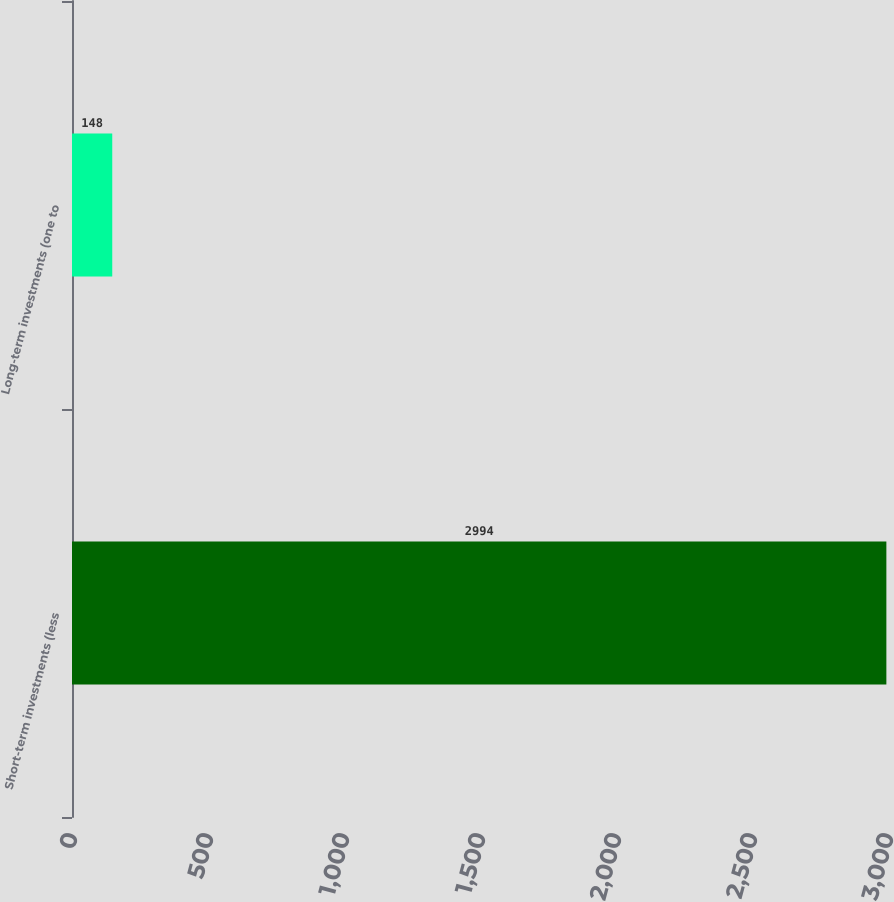Convert chart. <chart><loc_0><loc_0><loc_500><loc_500><bar_chart><fcel>Short-term investments (less<fcel>Long-term investments (one to<nl><fcel>2994<fcel>148<nl></chart> 